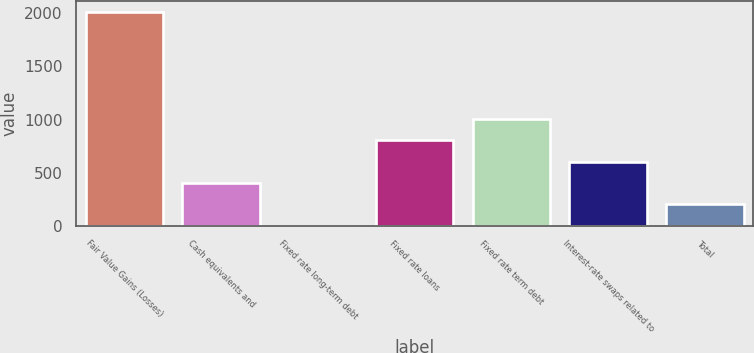Convert chart. <chart><loc_0><loc_0><loc_500><loc_500><bar_chart><fcel>Fair Value Gains (Losses)<fcel>Cash equivalents and<fcel>Fixed rate long-term debt<fcel>Fixed rate loans<fcel>Fixed rate term debt<fcel>Interest-rate swaps related to<fcel>Total<nl><fcel>2013<fcel>402.84<fcel>0.3<fcel>805.38<fcel>1006.65<fcel>604.11<fcel>201.57<nl></chart> 